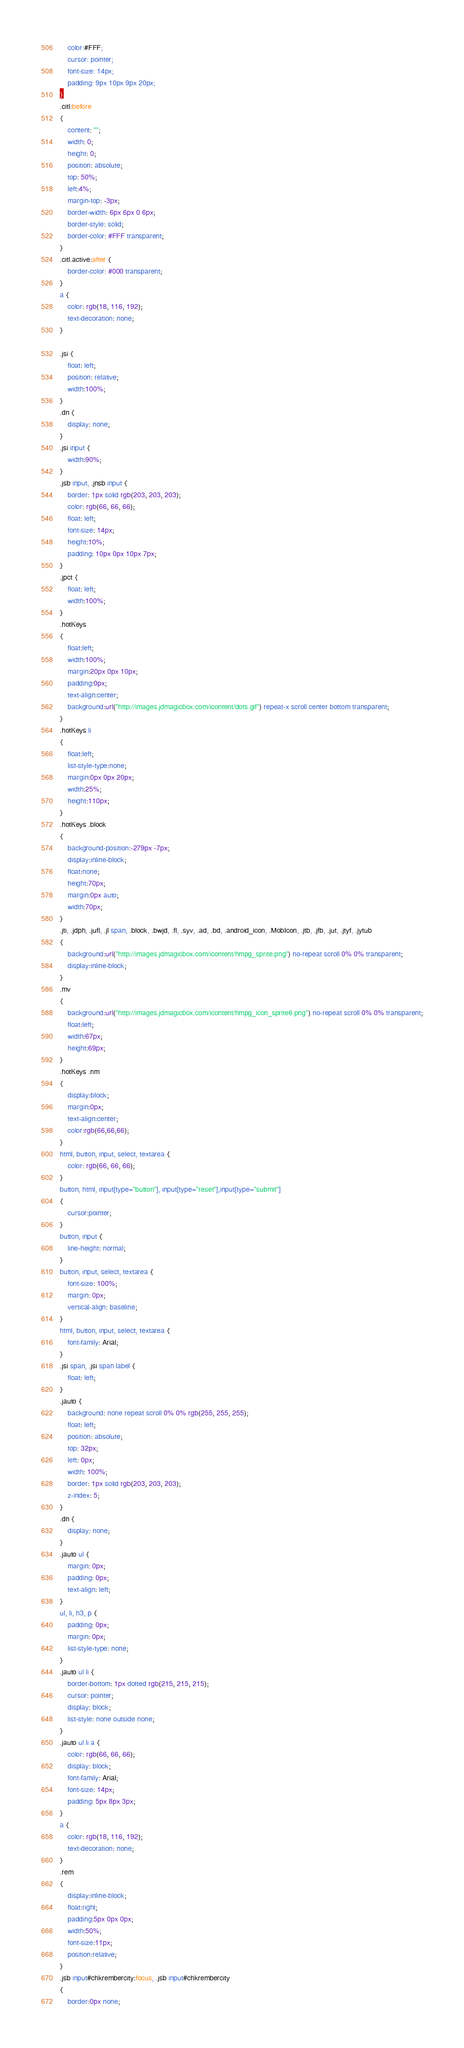Convert code to text. <code><loc_0><loc_0><loc_500><loc_500><_CSS_>    color:#FFF;
    cursor: pointer;
    font-size: 14px;
    padding: 9px 10px 9px 20px;
}
.citl:before
{
	content: "";
    width: 0;
    height: 0;
    position: absolute;
    top: 50%;
    left:4%;
    margin-top: -3px;
    border-width: 6px 6px 0 6px;
    border-style: solid;
    border-color: #FFF transparent;
}
.citl.active:after {
    border-color: #000 transparent;
}
a {
    color: rgb(18, 116, 192);
    text-decoration: none;
}

.jsi {
    float: left;
    position: relative;
    width:100%;
}
.dn {
    display: none;
}
.jsi input {
    width:90%;
}
.jsb input, .jnsb input {
    border: 1px solid rgb(203, 203, 203);
    color: rgb(66, 66, 66);
    float: left;
    font-size: 14px;
    height:10%;
    padding: 10px 0px 10px 7px;
}
.jpct {
    float: left;
    width:100%;
}
.hotKeys
{
	float:left;
	width:100%;
	margin:20px 0px 10px;
	padding:0px;
	text-align:center;
	background:url("http://images.jdmagicbox.com/icontent/dots.gif") repeat-x scroll center bottom transparent;
}
.hotKeys li
{
	float:left;
	list-style-type:none;
	margin:0px 0px 20px;
	width:25%;
	height:110px;
}
.hotKeys .block
{
	background-position:-279px -7px;
	display:inline-block;
	float:none;
	height:70px;
	margin:0px auto;
	width:70px;
}
.jti, .jdph, .jufl, .jl span, .block, .bwjd, .fl, .syv, .ad, .bd, .android_icon, .MobIcon, .jtb, .jfb, .jut, .jtyf, .jytub
{
	background:url("http://images.jdmagicbox.com/icontent/hmpg_sprite.png") no-repeat scroll 0% 0% transparent;
	display:inline-block;
}
.mv
{
	background:url("http://images.jdmagicbox.com/icontent/hmpg_icon_sprite6.png") no-repeat scroll 0% 0% transparent;
	float:left;
	width:67px;
	height:69px;
}
.hotKeys .nm
{
	display:block;
	margin:0px;
	text-align:center;
	color:rgb(66,66,66);
}
html, button, input, select, textarea {
    color: rgb(66, 66, 66);
}
button, html, input[type="button"], input[type="reset"],input[type="submit"]
{
	cursor:pointer;
}
button, input {
    line-height: normal;
}
button, input, select, textarea {
    font-size: 100%;
    margin: 0px;
    vertical-align: baseline;
}
html, button, input, select, textarea {
    font-family: Arial;
}
.jsi span, .jsi span label {
    float: left;
}
.jauto {
    background: none repeat scroll 0% 0% rgb(255, 255, 255);
    float: left;
    position: absolute;
    top: 32px;
    left: 0px;
    width: 100%;
    border: 1px solid rgb(203, 203, 203);
    z-index: 5;
}
.dn {
    display: none;
}
.jauto ul {
    margin: 0px;
    padding: 0px;
    text-align: left;
}
ul, li, h3, p {
    padding: 0px;
    margin: 0px;
    list-style-type: none;
}
.jauto ul li {
    border-bottom: 1px dotted rgb(215, 215, 215);
    cursor: pointer;
    display: block;
    list-style: none outside none;
}
.jauto ul li a {
    color: rgb(66, 66, 66);
    display: block;
    font-family: Arial;
    font-size: 14px;
    padding: 5px 8px 3px;
}
a {
    color: rgb(18, 116, 192);
    text-decoration: none;
}
.rem
{
	display:inline-block;
	float:right;
	padding:5px 0px 0px;
	width:50%;
	font-size:11px;
	position:relative;
}
.jsb input#chkrembercity:focus, .jsb input#chkrembercity
{
	border:0px none;</code> 